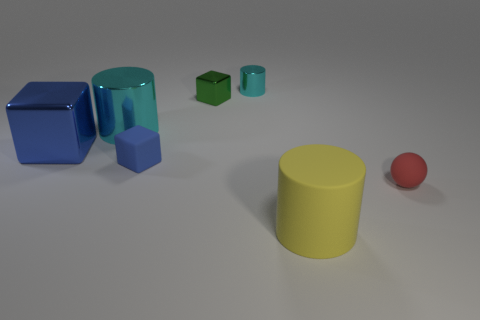What number of other things are there of the same material as the green thing
Offer a very short reply. 3. Are there an equal number of large matte cylinders that are to the left of the green shiny object and large things left of the large matte cylinder?
Your response must be concise. No. What number of large objects have the same shape as the tiny red object?
Offer a very short reply. 0. Are there any other tiny green objects that have the same material as the tiny green object?
Offer a very short reply. No. There is a object that is the same color as the large shiny block; what shape is it?
Keep it short and to the point. Cube. How many big cubes are there?
Give a very brief answer. 1. What number of balls are tiny red things or large blue metallic things?
Provide a succinct answer. 1. What is the color of the other cube that is the same size as the blue matte block?
Provide a short and direct response. Green. How many blue objects are both to the left of the big cyan cylinder and in front of the big shiny cube?
Your answer should be very brief. 0. What is the ball made of?
Provide a short and direct response. Rubber. 